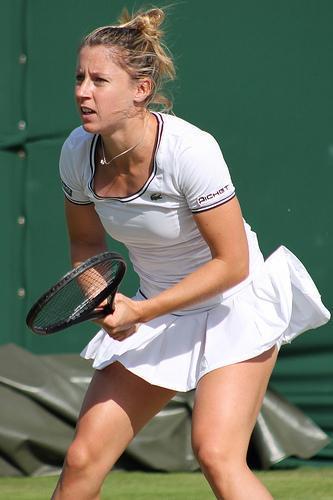How many players are in the picture?
Give a very brief answer. 1. 